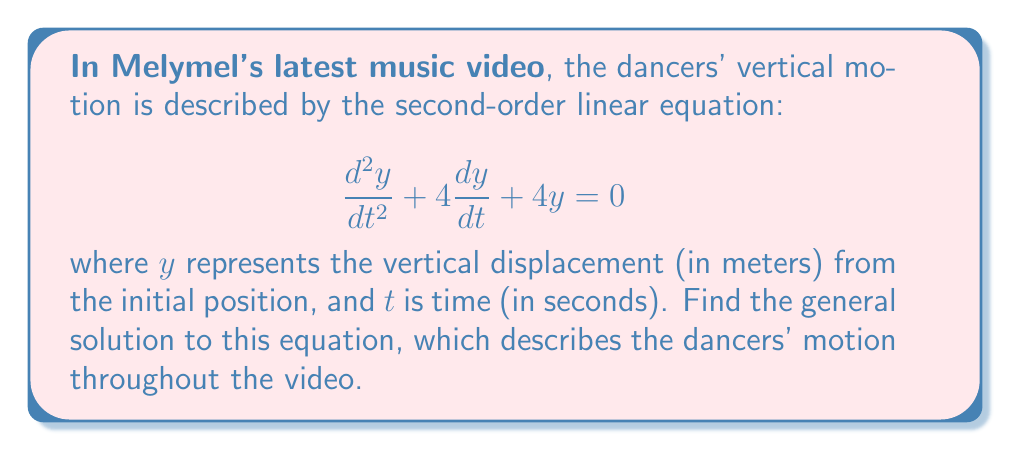Can you solve this math problem? Let's solve this step-by-step:

1) The characteristic equation for this second-order linear equation is:
   $$r^2 + 4r + 4 = 0$$

2) We can solve this using the quadratic formula: $r = \frac{-b \pm \sqrt{b^2 - 4ac}}{2a}$
   Here, $a=1$, $b=4$, and $c=4$

3) Substituting these values:
   $$r = \frac{-4 \pm \sqrt{16 - 16}}{2} = \frac{-4 \pm 0}{2} = -2$$

4) We have a repeated root $r = -2$

5) For a repeated root, the general solution takes the form:
   $$y(t) = (C_1 + C_2t)e^{rt}$$

6) Substituting $r = -2$:
   $$y(t) = (C_1 + C_2t)e^{-2t}$$

Where $C_1$ and $C_2$ are arbitrary constants determined by initial conditions.
Answer: $y(t) = (C_1 + C_2t)e^{-2t}$ 